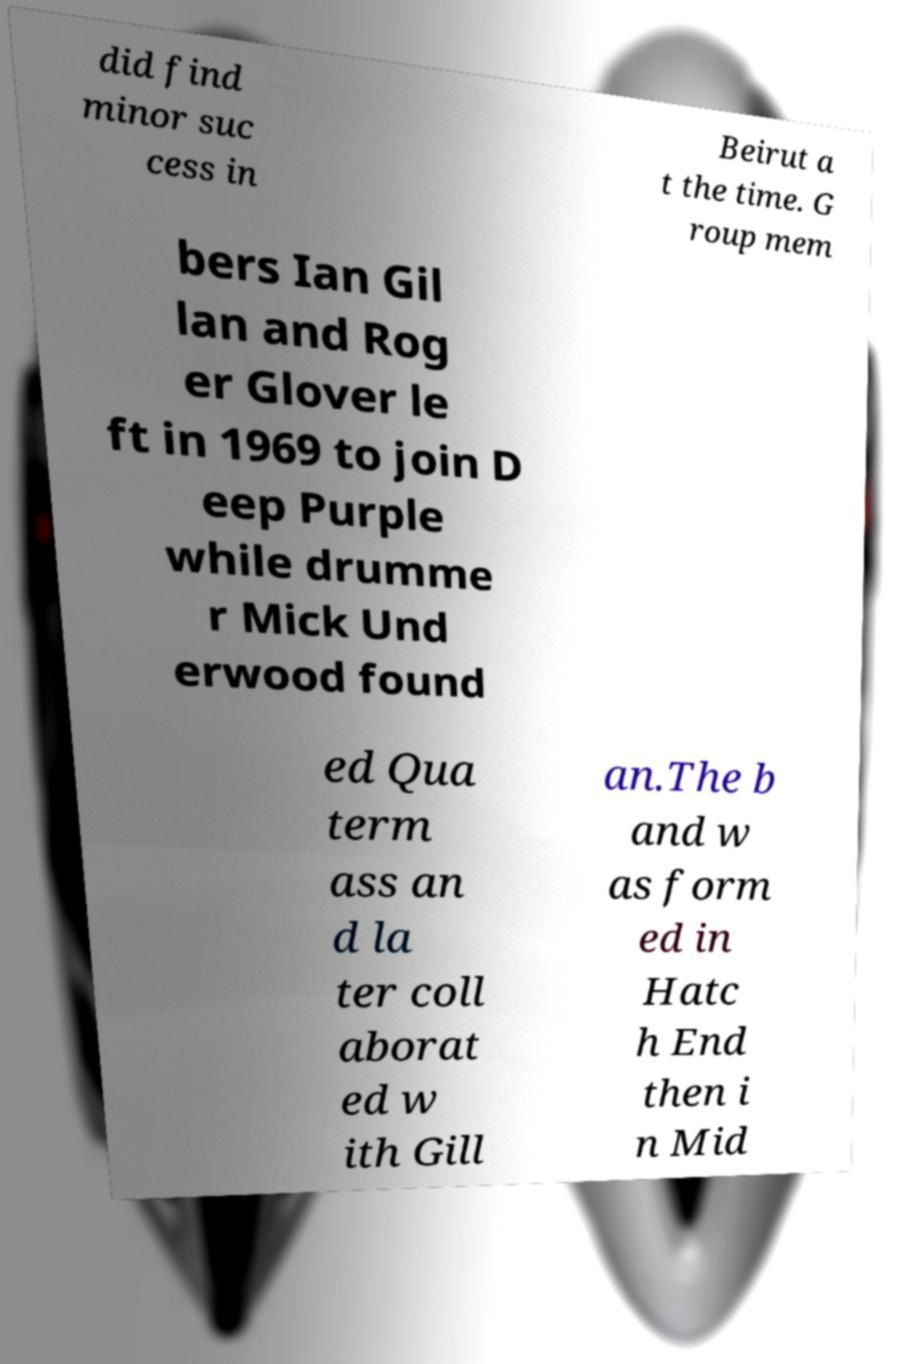Please read and relay the text visible in this image. What does it say? did find minor suc cess in Beirut a t the time. G roup mem bers Ian Gil lan and Rog er Glover le ft in 1969 to join D eep Purple while drumme r Mick Und erwood found ed Qua term ass an d la ter coll aborat ed w ith Gill an.The b and w as form ed in Hatc h End then i n Mid 